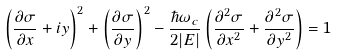<formula> <loc_0><loc_0><loc_500><loc_500>\left ( \frac { \partial \sigma } { \partial x } + i y \right ) ^ { 2 } + \left ( \frac { \partial \sigma } { \partial y } \right ) ^ { 2 } - \frac { \hbar { \omega } _ { c } } { 2 | E | } \left ( \frac { \partial ^ { 2 } \sigma } { \partial x ^ { 2 } } + \frac { \partial ^ { 2 } \sigma } { \partial y ^ { 2 } } \right ) = 1</formula> 